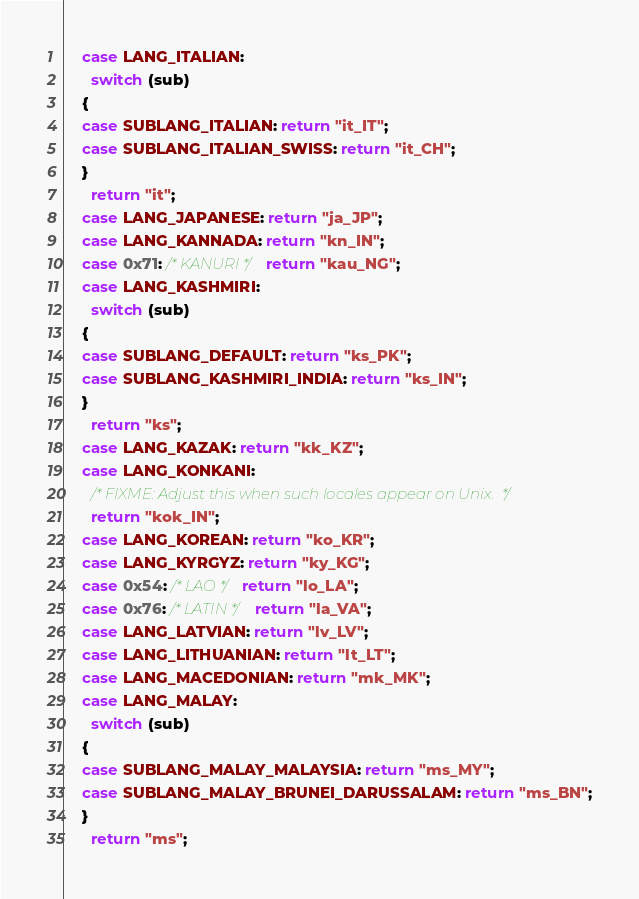<code> <loc_0><loc_0><loc_500><loc_500><_C_>    case LANG_ITALIAN:
      switch (sub)
	{
	case SUBLANG_ITALIAN: return "it_IT";
	case SUBLANG_ITALIAN_SWISS: return "it_CH";
	}
      return "it";
    case LANG_JAPANESE: return "ja_JP";
    case LANG_KANNADA: return "kn_IN";
    case 0x71: /* KANURI */ return "kau_NG";
    case LANG_KASHMIRI:
      switch (sub)
	{
	case SUBLANG_DEFAULT: return "ks_PK";
	case SUBLANG_KASHMIRI_INDIA: return "ks_IN";
	}
      return "ks";
    case LANG_KAZAK: return "kk_KZ";
    case LANG_KONKANI:
      /* FIXME: Adjust this when such locales appear on Unix.  */
      return "kok_IN";
    case LANG_KOREAN: return "ko_KR";
    case LANG_KYRGYZ: return "ky_KG";
    case 0x54: /* LAO */ return "lo_LA";
    case 0x76: /* LATIN */ return "la_VA";
    case LANG_LATVIAN: return "lv_LV";
    case LANG_LITHUANIAN: return "lt_LT";
    case LANG_MACEDONIAN: return "mk_MK";
    case LANG_MALAY:
      switch (sub)
	{
	case SUBLANG_MALAY_MALAYSIA: return "ms_MY";
	case SUBLANG_MALAY_BRUNEI_DARUSSALAM: return "ms_BN";
	}
      return "ms";</code> 